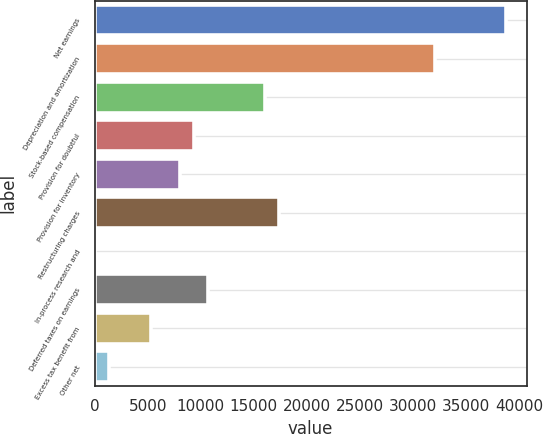Convert chart. <chart><loc_0><loc_0><loc_500><loc_500><bar_chart><fcel>Net earnings<fcel>Depreciation and amortization<fcel>Stock-based compensation<fcel>Provision for doubtful<fcel>Provision for inventory<fcel>Restructuring charges<fcel>In-process research and<fcel>Deferred taxes on earnings<fcel>Excess tax benefit from<fcel>Other net<nl><fcel>38785.8<fcel>32099.8<fcel>16053.4<fcel>9367.4<fcel>8030.2<fcel>17390.6<fcel>7<fcel>10704.6<fcel>5355.8<fcel>1344.2<nl></chart> 